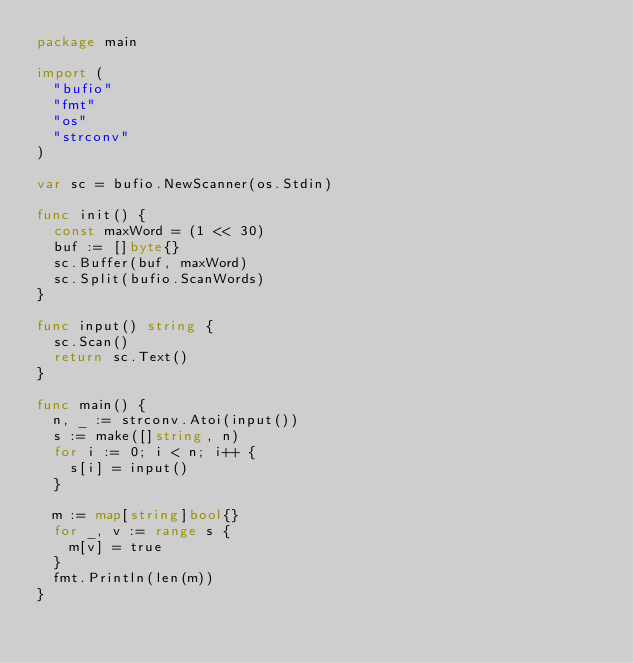Convert code to text. <code><loc_0><loc_0><loc_500><loc_500><_Go_>package main

import (
	"bufio"
	"fmt"
	"os"
	"strconv"
)

var sc = bufio.NewScanner(os.Stdin)

func init() {
	const maxWord = (1 << 30)
	buf := []byte{}
	sc.Buffer(buf, maxWord)
	sc.Split(bufio.ScanWords)
}

func input() string {
	sc.Scan()
	return sc.Text()
}

func main() {
	n, _ := strconv.Atoi(input())
	s := make([]string, n)
	for i := 0; i < n; i++ {
		s[i] = input()
	}

	m := map[string]bool{}
	for _, v := range s {
		m[v] = true
	}
	fmt.Println(len(m))
}
</code> 